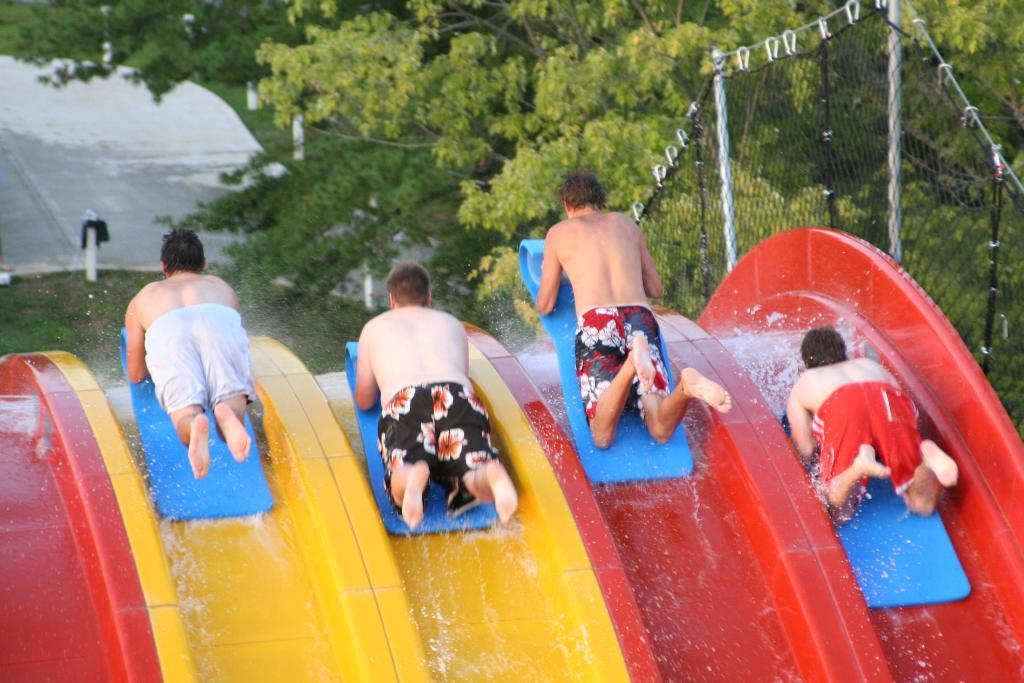How many people are in the image? There are four persons in the image. What are the persons doing in the image? The persons are lying on a blue object. What is the blue object on? The blue object is on a water slide. What can be seen in the background of the image? There are trees in the background of the image. What type of straw is being used to trade in the image? There is no straw or trading activity present in the image. 